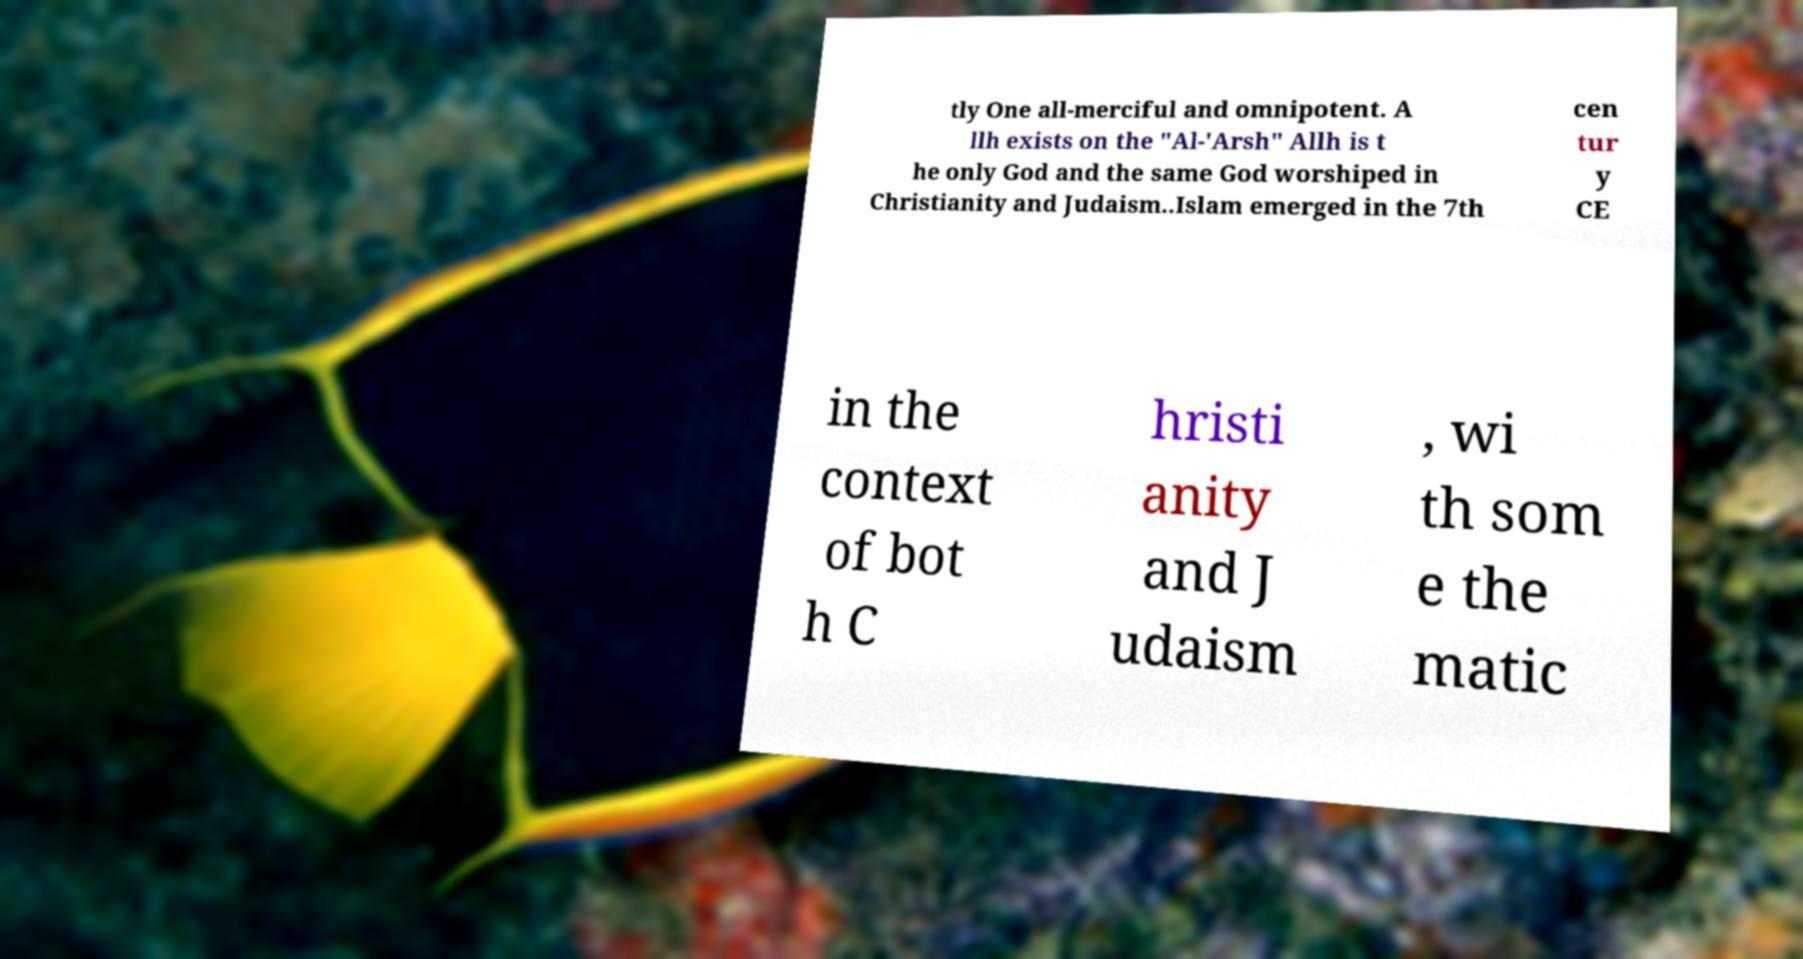There's text embedded in this image that I need extracted. Can you transcribe it verbatim? tly One all-merciful and omnipotent. A llh exists on the "Al-'Arsh" Allh is t he only God and the same God worshiped in Christianity and Judaism..Islam emerged in the 7th cen tur y CE in the context of bot h C hristi anity and J udaism , wi th som e the matic 